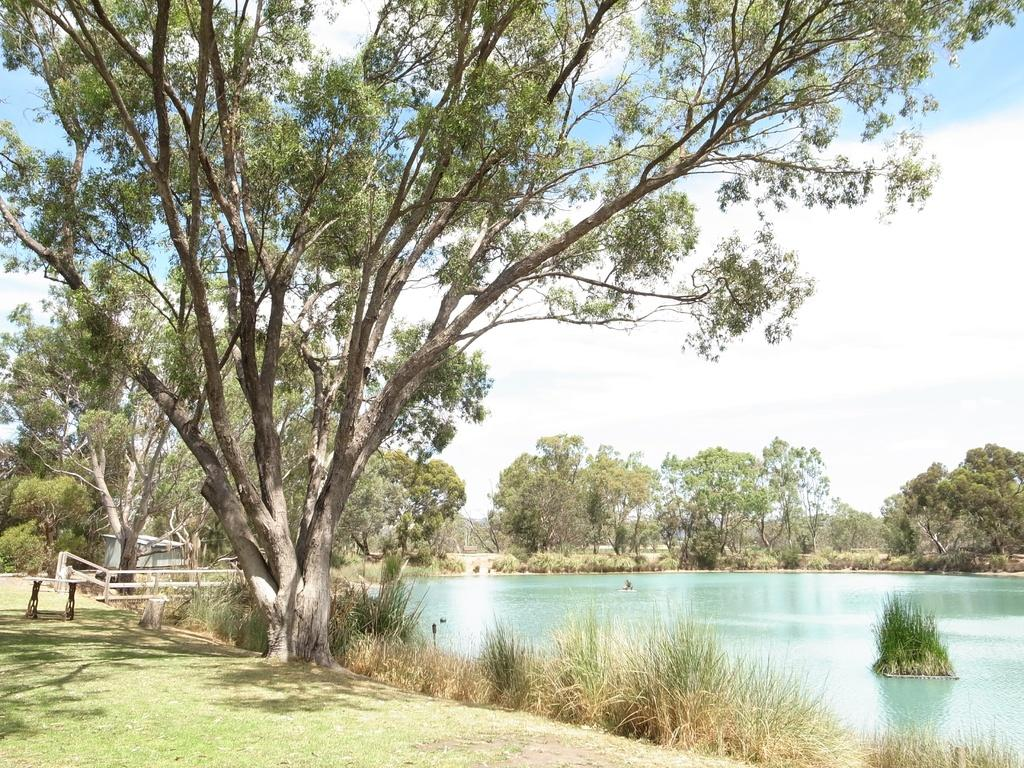What type of vegetation can be seen in the image? There are trees and grass in the image. What natural feature is present in the image? There is a river in the image. What type of seating is available in the image? There is a bench in the image. What type of barrier is present in front of the house in the image? There is a wooden fence in front of the house in the image. What is visible in the background of the image? The sky is visible in the background of the image. How many kittens are playing with the babies in the image? There are no kittens or babies present in the image. 